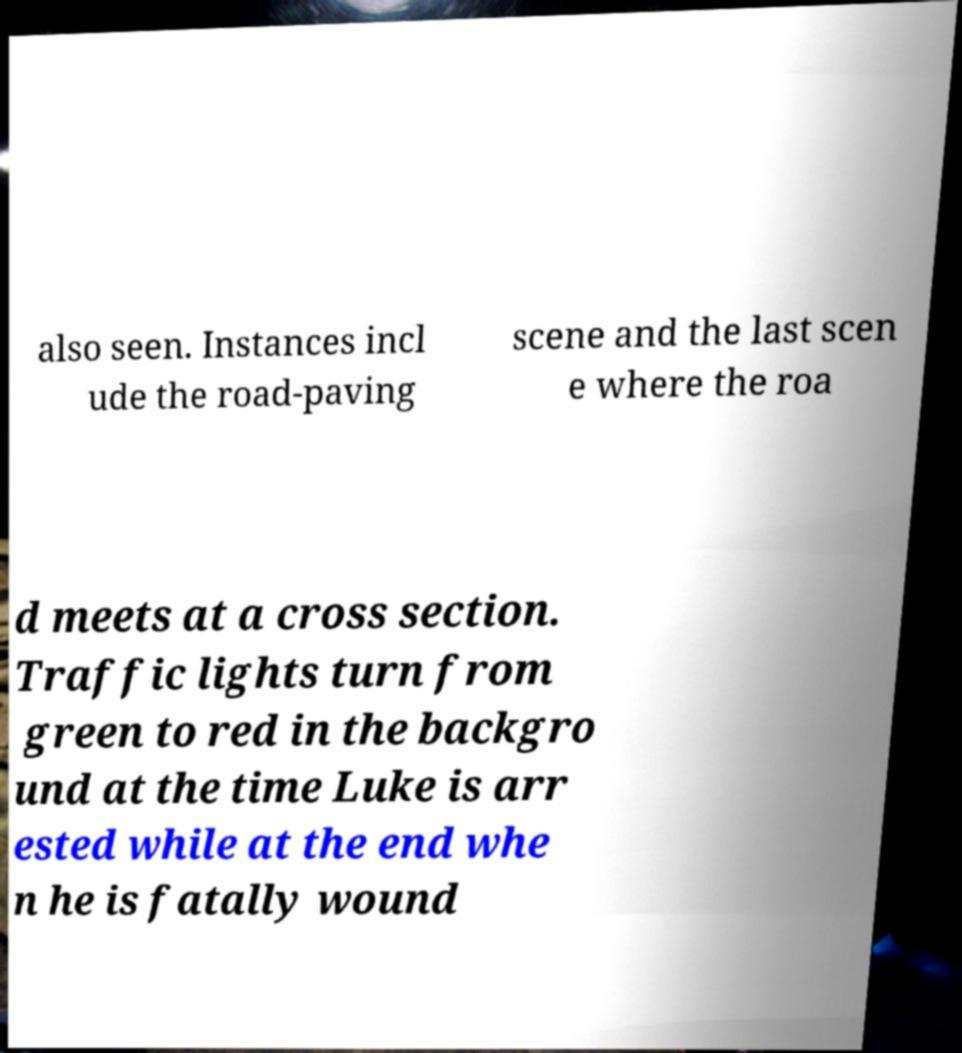For documentation purposes, I need the text within this image transcribed. Could you provide that? also seen. Instances incl ude the road-paving scene and the last scen e where the roa d meets at a cross section. Traffic lights turn from green to red in the backgro und at the time Luke is arr ested while at the end whe n he is fatally wound 